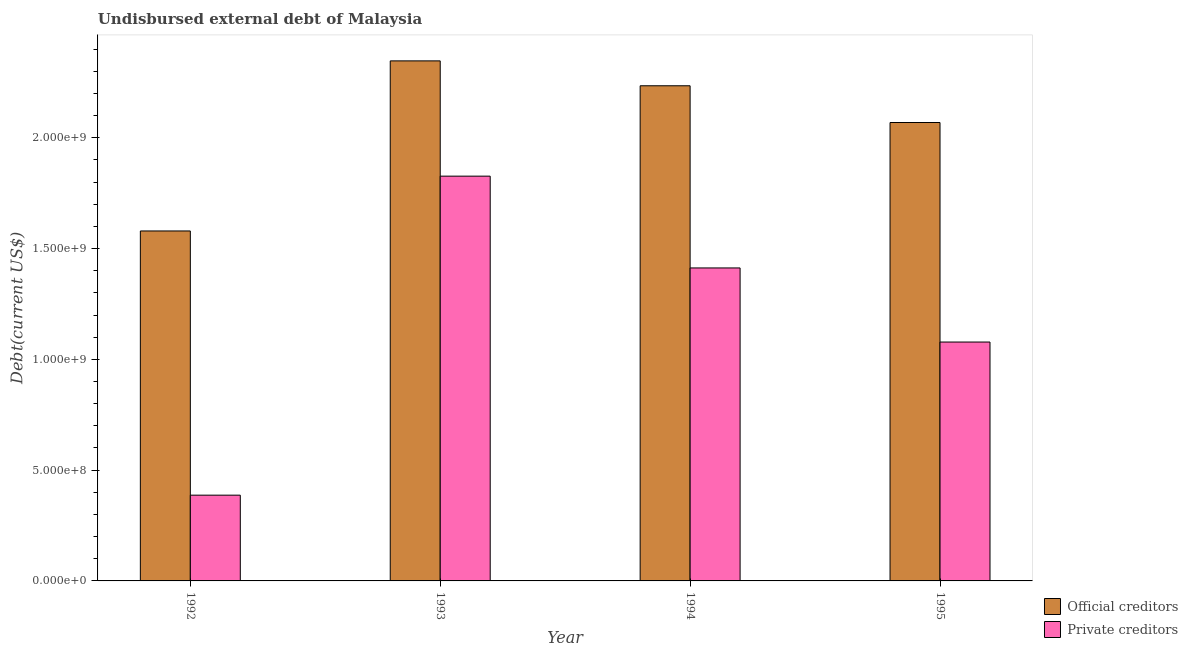How many different coloured bars are there?
Your answer should be compact. 2. Are the number of bars per tick equal to the number of legend labels?
Offer a terse response. Yes. How many bars are there on the 4th tick from the left?
Offer a very short reply. 2. In how many cases, is the number of bars for a given year not equal to the number of legend labels?
Offer a very short reply. 0. What is the undisbursed external debt of private creditors in 1992?
Provide a short and direct response. 3.87e+08. Across all years, what is the maximum undisbursed external debt of private creditors?
Keep it short and to the point. 1.83e+09. Across all years, what is the minimum undisbursed external debt of private creditors?
Your response must be concise. 3.87e+08. In which year was the undisbursed external debt of private creditors maximum?
Make the answer very short. 1993. In which year was the undisbursed external debt of official creditors minimum?
Provide a short and direct response. 1992. What is the total undisbursed external debt of official creditors in the graph?
Offer a terse response. 8.23e+09. What is the difference between the undisbursed external debt of official creditors in 1993 and that in 1995?
Offer a terse response. 2.78e+08. What is the difference between the undisbursed external debt of official creditors in 1995 and the undisbursed external debt of private creditors in 1993?
Provide a succinct answer. -2.78e+08. What is the average undisbursed external debt of official creditors per year?
Your response must be concise. 2.06e+09. What is the ratio of the undisbursed external debt of official creditors in 1993 to that in 1994?
Ensure brevity in your answer.  1.05. What is the difference between the highest and the second highest undisbursed external debt of official creditors?
Give a very brief answer. 1.12e+08. What is the difference between the highest and the lowest undisbursed external debt of official creditors?
Offer a terse response. 7.68e+08. In how many years, is the undisbursed external debt of private creditors greater than the average undisbursed external debt of private creditors taken over all years?
Your answer should be very brief. 2. Is the sum of the undisbursed external debt of official creditors in 1992 and 1994 greater than the maximum undisbursed external debt of private creditors across all years?
Provide a short and direct response. Yes. What does the 1st bar from the left in 1993 represents?
Keep it short and to the point. Official creditors. What does the 2nd bar from the right in 1993 represents?
Offer a terse response. Official creditors. What is the difference between two consecutive major ticks on the Y-axis?
Give a very brief answer. 5.00e+08. Are the values on the major ticks of Y-axis written in scientific E-notation?
Your response must be concise. Yes. Where does the legend appear in the graph?
Give a very brief answer. Bottom right. How many legend labels are there?
Provide a short and direct response. 2. How are the legend labels stacked?
Keep it short and to the point. Vertical. What is the title of the graph?
Make the answer very short. Undisbursed external debt of Malaysia. What is the label or title of the X-axis?
Make the answer very short. Year. What is the label or title of the Y-axis?
Provide a short and direct response. Debt(current US$). What is the Debt(current US$) of Official creditors in 1992?
Give a very brief answer. 1.58e+09. What is the Debt(current US$) of Private creditors in 1992?
Provide a short and direct response. 3.87e+08. What is the Debt(current US$) in Official creditors in 1993?
Ensure brevity in your answer.  2.35e+09. What is the Debt(current US$) of Private creditors in 1993?
Offer a very short reply. 1.83e+09. What is the Debt(current US$) in Official creditors in 1994?
Offer a terse response. 2.23e+09. What is the Debt(current US$) of Private creditors in 1994?
Your answer should be very brief. 1.41e+09. What is the Debt(current US$) of Official creditors in 1995?
Ensure brevity in your answer.  2.07e+09. What is the Debt(current US$) in Private creditors in 1995?
Provide a short and direct response. 1.08e+09. Across all years, what is the maximum Debt(current US$) in Official creditors?
Your response must be concise. 2.35e+09. Across all years, what is the maximum Debt(current US$) of Private creditors?
Your answer should be very brief. 1.83e+09. Across all years, what is the minimum Debt(current US$) in Official creditors?
Provide a succinct answer. 1.58e+09. Across all years, what is the minimum Debt(current US$) of Private creditors?
Your answer should be compact. 3.87e+08. What is the total Debt(current US$) of Official creditors in the graph?
Give a very brief answer. 8.23e+09. What is the total Debt(current US$) in Private creditors in the graph?
Your answer should be compact. 4.70e+09. What is the difference between the Debt(current US$) in Official creditors in 1992 and that in 1993?
Offer a terse response. -7.68e+08. What is the difference between the Debt(current US$) of Private creditors in 1992 and that in 1993?
Your response must be concise. -1.44e+09. What is the difference between the Debt(current US$) of Official creditors in 1992 and that in 1994?
Ensure brevity in your answer.  -6.55e+08. What is the difference between the Debt(current US$) in Private creditors in 1992 and that in 1994?
Offer a terse response. -1.03e+09. What is the difference between the Debt(current US$) of Official creditors in 1992 and that in 1995?
Ensure brevity in your answer.  -4.89e+08. What is the difference between the Debt(current US$) of Private creditors in 1992 and that in 1995?
Offer a terse response. -6.91e+08. What is the difference between the Debt(current US$) of Official creditors in 1993 and that in 1994?
Your answer should be compact. 1.12e+08. What is the difference between the Debt(current US$) in Private creditors in 1993 and that in 1994?
Make the answer very short. 4.14e+08. What is the difference between the Debt(current US$) of Official creditors in 1993 and that in 1995?
Make the answer very short. 2.78e+08. What is the difference between the Debt(current US$) in Private creditors in 1993 and that in 1995?
Your answer should be compact. 7.49e+08. What is the difference between the Debt(current US$) of Official creditors in 1994 and that in 1995?
Ensure brevity in your answer.  1.66e+08. What is the difference between the Debt(current US$) of Private creditors in 1994 and that in 1995?
Provide a succinct answer. 3.34e+08. What is the difference between the Debt(current US$) in Official creditors in 1992 and the Debt(current US$) in Private creditors in 1993?
Offer a very short reply. -2.47e+08. What is the difference between the Debt(current US$) of Official creditors in 1992 and the Debt(current US$) of Private creditors in 1994?
Provide a short and direct response. 1.67e+08. What is the difference between the Debt(current US$) in Official creditors in 1992 and the Debt(current US$) in Private creditors in 1995?
Keep it short and to the point. 5.01e+08. What is the difference between the Debt(current US$) of Official creditors in 1993 and the Debt(current US$) of Private creditors in 1994?
Provide a short and direct response. 9.35e+08. What is the difference between the Debt(current US$) of Official creditors in 1993 and the Debt(current US$) of Private creditors in 1995?
Make the answer very short. 1.27e+09. What is the difference between the Debt(current US$) in Official creditors in 1994 and the Debt(current US$) in Private creditors in 1995?
Provide a short and direct response. 1.16e+09. What is the average Debt(current US$) in Official creditors per year?
Offer a terse response. 2.06e+09. What is the average Debt(current US$) in Private creditors per year?
Offer a very short reply. 1.18e+09. In the year 1992, what is the difference between the Debt(current US$) in Official creditors and Debt(current US$) in Private creditors?
Your response must be concise. 1.19e+09. In the year 1993, what is the difference between the Debt(current US$) of Official creditors and Debt(current US$) of Private creditors?
Make the answer very short. 5.20e+08. In the year 1994, what is the difference between the Debt(current US$) in Official creditors and Debt(current US$) in Private creditors?
Provide a succinct answer. 8.22e+08. In the year 1995, what is the difference between the Debt(current US$) of Official creditors and Debt(current US$) of Private creditors?
Provide a succinct answer. 9.91e+08. What is the ratio of the Debt(current US$) in Official creditors in 1992 to that in 1993?
Provide a succinct answer. 0.67. What is the ratio of the Debt(current US$) in Private creditors in 1992 to that in 1993?
Make the answer very short. 0.21. What is the ratio of the Debt(current US$) of Official creditors in 1992 to that in 1994?
Your answer should be very brief. 0.71. What is the ratio of the Debt(current US$) in Private creditors in 1992 to that in 1994?
Your answer should be compact. 0.27. What is the ratio of the Debt(current US$) of Official creditors in 1992 to that in 1995?
Give a very brief answer. 0.76. What is the ratio of the Debt(current US$) in Private creditors in 1992 to that in 1995?
Provide a succinct answer. 0.36. What is the ratio of the Debt(current US$) of Official creditors in 1993 to that in 1994?
Give a very brief answer. 1.05. What is the ratio of the Debt(current US$) of Private creditors in 1993 to that in 1994?
Give a very brief answer. 1.29. What is the ratio of the Debt(current US$) of Official creditors in 1993 to that in 1995?
Offer a very short reply. 1.13. What is the ratio of the Debt(current US$) of Private creditors in 1993 to that in 1995?
Keep it short and to the point. 1.69. What is the ratio of the Debt(current US$) in Official creditors in 1994 to that in 1995?
Give a very brief answer. 1.08. What is the ratio of the Debt(current US$) in Private creditors in 1994 to that in 1995?
Give a very brief answer. 1.31. What is the difference between the highest and the second highest Debt(current US$) of Official creditors?
Your answer should be compact. 1.12e+08. What is the difference between the highest and the second highest Debt(current US$) of Private creditors?
Provide a succinct answer. 4.14e+08. What is the difference between the highest and the lowest Debt(current US$) of Official creditors?
Provide a short and direct response. 7.68e+08. What is the difference between the highest and the lowest Debt(current US$) of Private creditors?
Offer a terse response. 1.44e+09. 